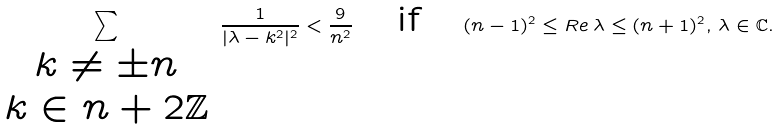<formula> <loc_0><loc_0><loc_500><loc_500>\sum _ { \begin{array} { c } k \neq \pm n \\ k \in n + 2 \mathbb { Z } \end{array} } \frac { 1 } { | \lambda - k ^ { 2 } | ^ { 2 } } < \frac { 9 } { n ^ { 2 } } \quad \text {if} \quad ( n - 1 ) ^ { 2 } \leq R e \, \lambda \leq ( n + 1 ) ^ { 2 } , \, \lambda \in \mathbb { C } .</formula> 